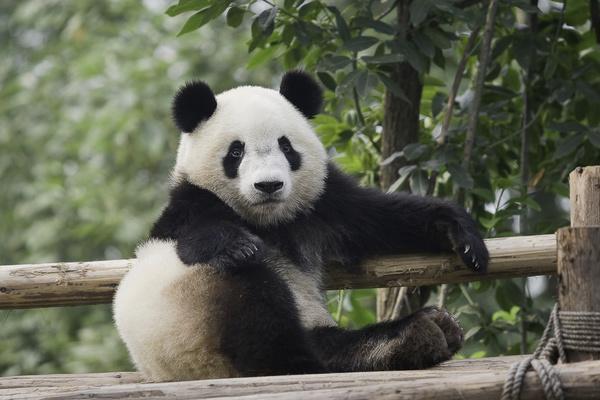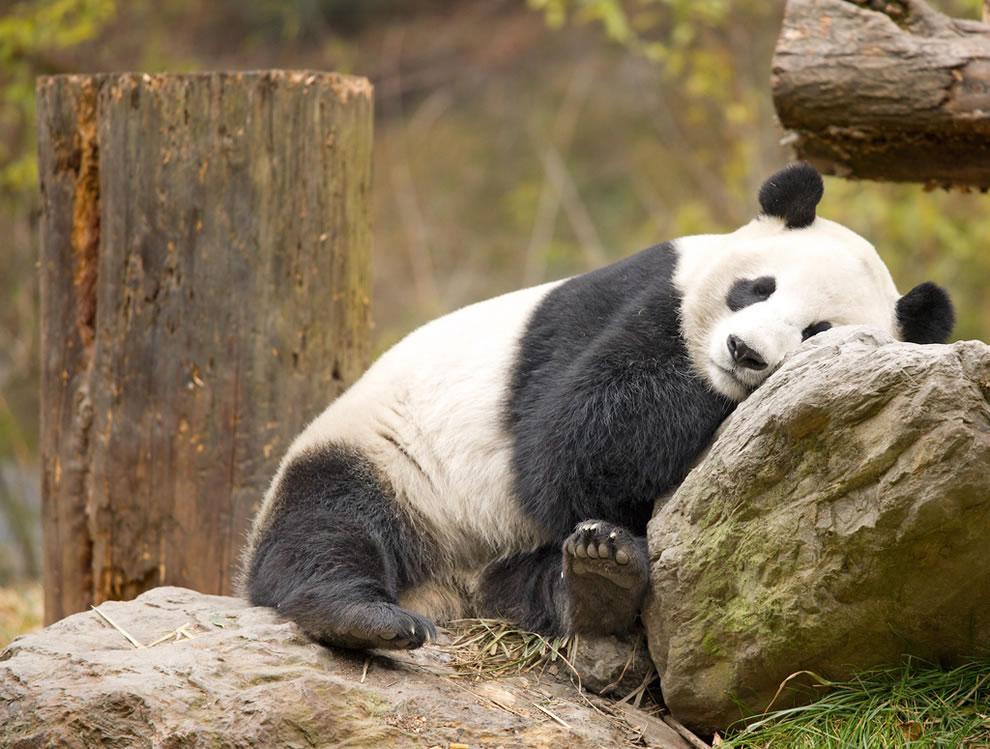The first image is the image on the left, the second image is the image on the right. Given the left and right images, does the statement "In one image there is a panda bear sleeping on a log." hold true? Answer yes or no. No. The first image is the image on the left, the second image is the image on the right. Considering the images on both sides, is "One of the pandas is lounging on a large rock." valid? Answer yes or no. Yes. 